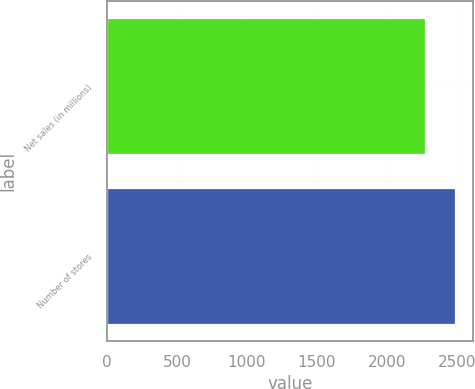Convert chart to OTSL. <chart><loc_0><loc_0><loc_500><loc_500><bar_chart><fcel>Net sales (in millions)<fcel>Number of stores<nl><fcel>2269.5<fcel>2490<nl></chart> 